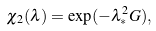Convert formula to latex. <formula><loc_0><loc_0><loc_500><loc_500>\chi _ { 2 } ( \lambda ) = \exp ( - \lambda ^ { 2 } _ { \ast } G ) ,</formula> 